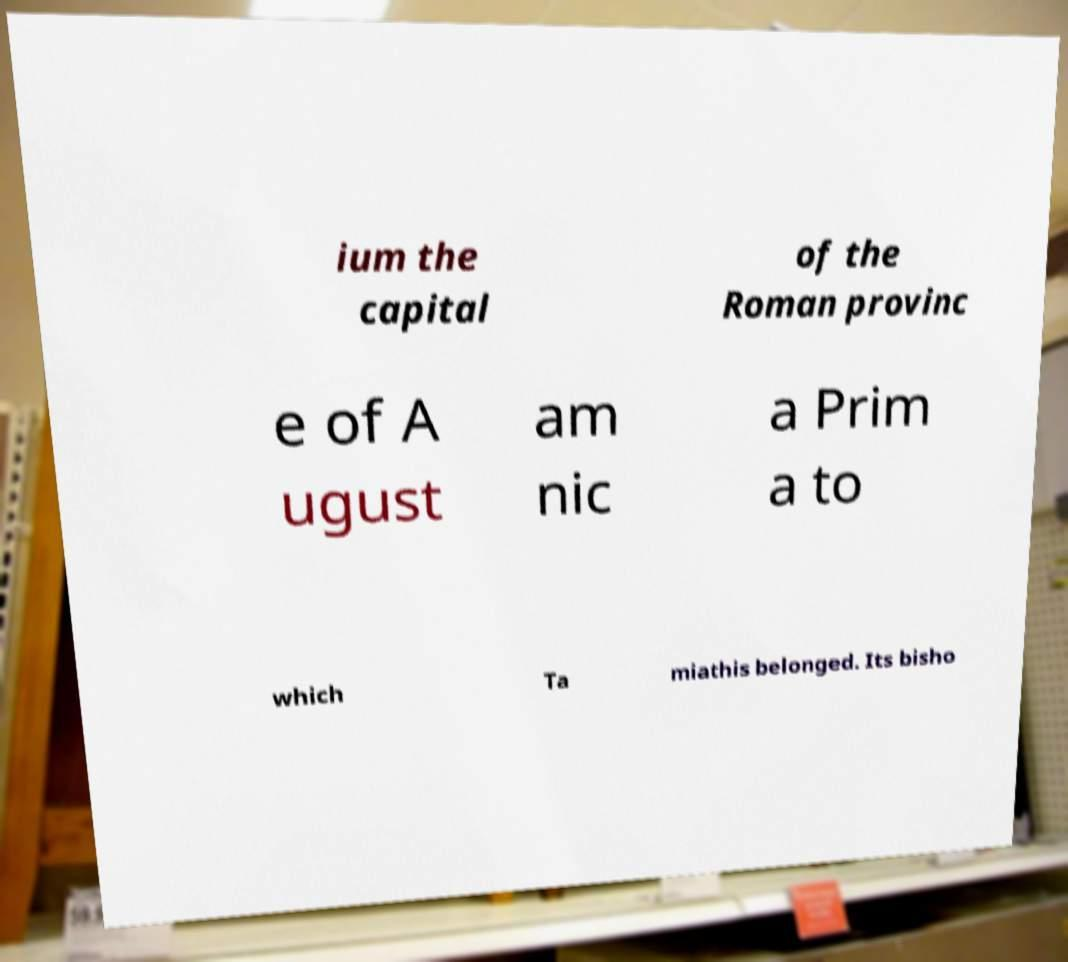I need the written content from this picture converted into text. Can you do that? ium the capital of the Roman provinc e of A ugust am nic a Prim a to which Ta miathis belonged. Its bisho 